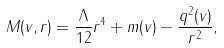Convert formula to latex. <formula><loc_0><loc_0><loc_500><loc_500>M ( v , r ) = \frac { \Lambda } { 1 2 } r ^ { 4 } + m ( v ) - \frac { q ^ { 2 } ( v ) } { r ^ { 2 } } ,</formula> 